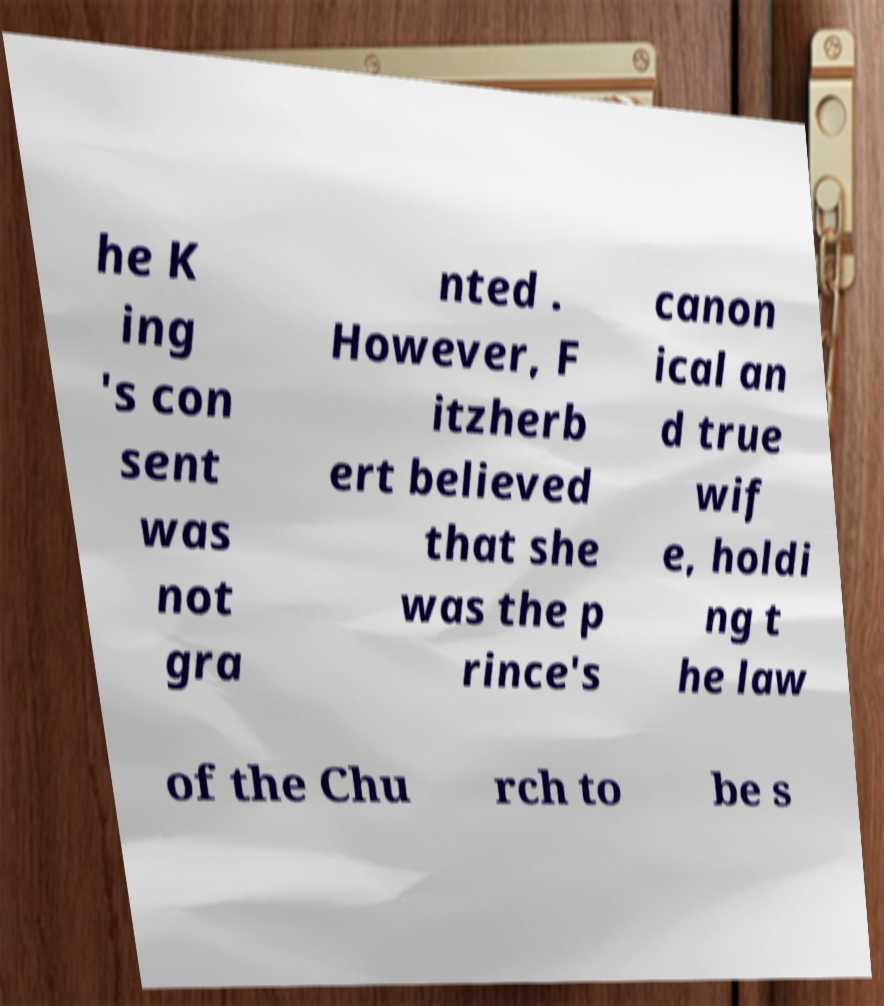Can you accurately transcribe the text from the provided image for me? he K ing 's con sent was not gra nted . However, F itzherb ert believed that she was the p rince's canon ical an d true wif e, holdi ng t he law of the Chu rch to be s 